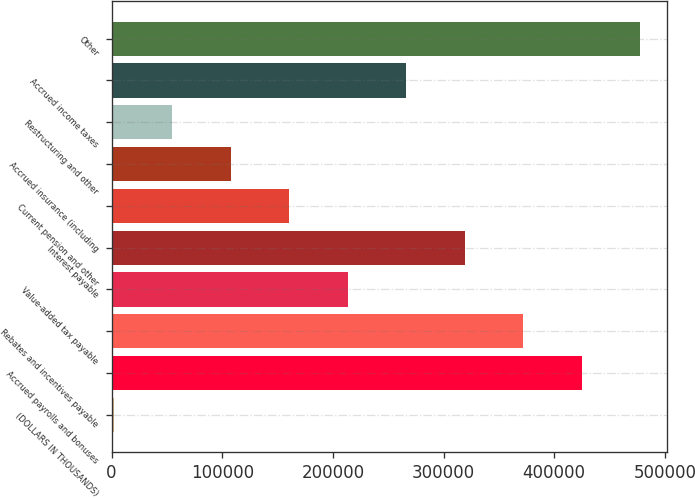Convert chart. <chart><loc_0><loc_0><loc_500><loc_500><bar_chart><fcel>(DOLLARS IN THOUSANDS)<fcel>Accrued payrolls and bonuses<fcel>Rebates and incentives payable<fcel>Value-added tax payable<fcel>Interest payable<fcel>Current pension and other<fcel>Accrued insurance (including<fcel>Restructuring and other<fcel>Accrued income taxes<fcel>Other<nl><fcel>2018<fcel>424810<fcel>371961<fcel>213414<fcel>319112<fcel>160565<fcel>107716<fcel>54867<fcel>266263<fcel>477659<nl></chart> 